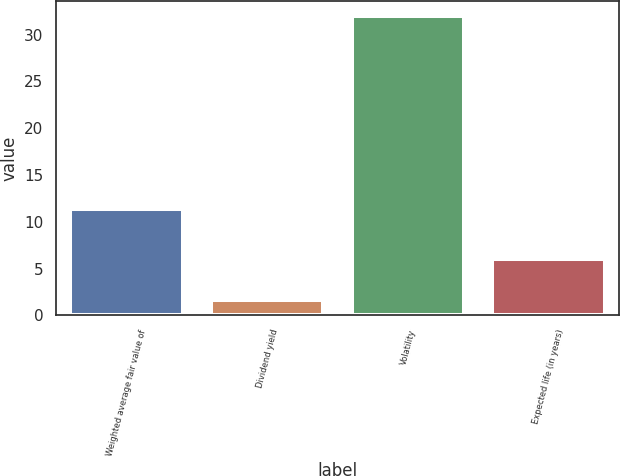Convert chart. <chart><loc_0><loc_0><loc_500><loc_500><bar_chart><fcel>Weighted average fair value of<fcel>Dividend yield<fcel>Volatility<fcel>Expected life (in years)<nl><fcel>11.4<fcel>1.59<fcel>32<fcel>5.98<nl></chart> 